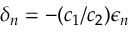Convert formula to latex. <formula><loc_0><loc_0><loc_500><loc_500>\delta _ { n } = - ( c _ { 1 } / c _ { 2 } ) \epsilon _ { n }</formula> 